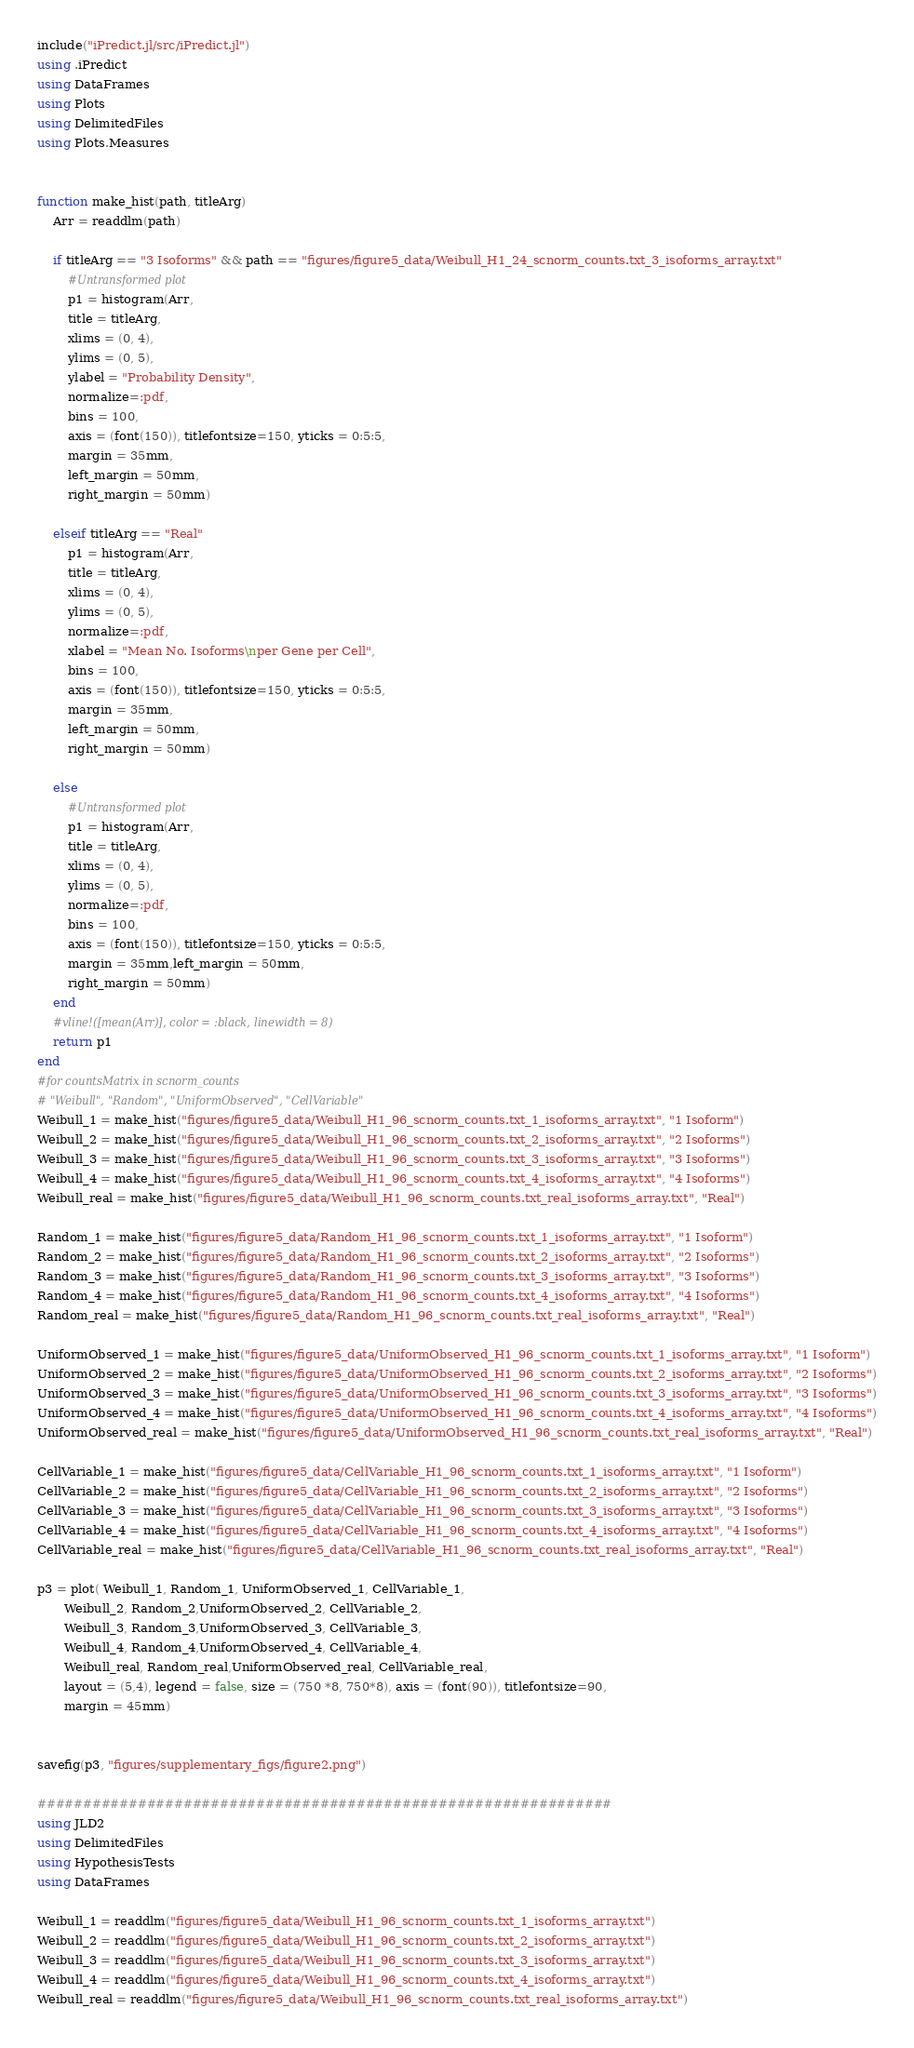<code> <loc_0><loc_0><loc_500><loc_500><_Julia_>include("iPredict.jl/src/iPredict.jl")
using .iPredict
using DataFrames
using Plots
using DelimitedFiles
using Plots.Measures


function make_hist(path, titleArg)
    Arr = readdlm(path)

    if titleArg == "3 Isoforms" && path == "figures/figure5_data/Weibull_H1_24_scnorm_counts.txt_3_isoforms_array.txt"
        #Untransformed plot
        p1 = histogram(Arr,
        title = titleArg,
        xlims = (0, 4),
        ylims = (0, 5),
        ylabel = "Probability Density",
        normalize=:pdf,
        bins = 100,
        axis = (font(150)), titlefontsize=150, yticks = 0:5:5,
        margin = 35mm,
        left_margin = 50mm,
        right_margin = 50mm)

    elseif titleArg == "Real"
        p1 = histogram(Arr,
        title = titleArg,
        xlims = (0, 4),
        ylims = (0, 5),
        normalize=:pdf,
        xlabel = "Mean No. Isoforms\nper Gene per Cell",
        bins = 100,
        axis = (font(150)), titlefontsize=150, yticks = 0:5:5,
        margin = 35mm,
        left_margin = 50mm,
        right_margin = 50mm)

    else
        #Untransformed plot
        p1 = histogram(Arr,
        title = titleArg,
        xlims = (0, 4),
        ylims = (0, 5),
        normalize=:pdf,
        bins = 100,
        axis = (font(150)), titlefontsize=150, yticks = 0:5:5,
        margin = 35mm,left_margin = 50mm,
        right_margin = 50mm)
    end
    #vline!([mean(Arr)], color = :black, linewidth = 8)
    return p1
end
#for countsMatrix in scnorm_counts
# "Weibull", "Random", "UniformObserved", "CellVariable"
Weibull_1 = make_hist("figures/figure5_data/Weibull_H1_96_scnorm_counts.txt_1_isoforms_array.txt", "1 Isoform")
Weibull_2 = make_hist("figures/figure5_data/Weibull_H1_96_scnorm_counts.txt_2_isoforms_array.txt", "2 Isoforms")
Weibull_3 = make_hist("figures/figure5_data/Weibull_H1_96_scnorm_counts.txt_3_isoforms_array.txt", "3 Isoforms")
Weibull_4 = make_hist("figures/figure5_data/Weibull_H1_96_scnorm_counts.txt_4_isoforms_array.txt", "4 Isoforms")
Weibull_real = make_hist("figures/figure5_data/Weibull_H1_96_scnorm_counts.txt_real_isoforms_array.txt", "Real")

Random_1 = make_hist("figures/figure5_data/Random_H1_96_scnorm_counts.txt_1_isoforms_array.txt", "1 Isoform")
Random_2 = make_hist("figures/figure5_data/Random_H1_96_scnorm_counts.txt_2_isoforms_array.txt", "2 Isoforms")
Random_3 = make_hist("figures/figure5_data/Random_H1_96_scnorm_counts.txt_3_isoforms_array.txt", "3 Isoforms")
Random_4 = make_hist("figures/figure5_data/Random_H1_96_scnorm_counts.txt_4_isoforms_array.txt", "4 Isoforms")
Random_real = make_hist("figures/figure5_data/Random_H1_96_scnorm_counts.txt_real_isoforms_array.txt", "Real")

UniformObserved_1 = make_hist("figures/figure5_data/UniformObserved_H1_96_scnorm_counts.txt_1_isoforms_array.txt", "1 Isoform")
UniformObserved_2 = make_hist("figures/figure5_data/UniformObserved_H1_96_scnorm_counts.txt_2_isoforms_array.txt", "2 Isoforms")
UniformObserved_3 = make_hist("figures/figure5_data/UniformObserved_H1_96_scnorm_counts.txt_3_isoforms_array.txt", "3 Isoforms")
UniformObserved_4 = make_hist("figures/figure5_data/UniformObserved_H1_96_scnorm_counts.txt_4_isoforms_array.txt", "4 Isoforms")
UniformObserved_real = make_hist("figures/figure5_data/UniformObserved_H1_96_scnorm_counts.txt_real_isoforms_array.txt", "Real")

CellVariable_1 = make_hist("figures/figure5_data/CellVariable_H1_96_scnorm_counts.txt_1_isoforms_array.txt", "1 Isoform")
CellVariable_2 = make_hist("figures/figure5_data/CellVariable_H1_96_scnorm_counts.txt_2_isoforms_array.txt", "2 Isoforms")
CellVariable_3 = make_hist("figures/figure5_data/CellVariable_H1_96_scnorm_counts.txt_3_isoforms_array.txt", "3 Isoforms")
CellVariable_4 = make_hist("figures/figure5_data/CellVariable_H1_96_scnorm_counts.txt_4_isoforms_array.txt", "4 Isoforms")
CellVariable_real = make_hist("figures/figure5_data/CellVariable_H1_96_scnorm_counts.txt_real_isoforms_array.txt", "Real")

p3 = plot( Weibull_1, Random_1, UniformObserved_1, CellVariable_1,
       Weibull_2, Random_2,UniformObserved_2, CellVariable_2,
       Weibull_3, Random_3,UniformObserved_3, CellVariable_3,
       Weibull_4, Random_4,UniformObserved_4, CellVariable_4,
       Weibull_real, Random_real,UniformObserved_real, CellVariable_real,
       layout = (5,4), legend = false, size = (750 *8, 750*8), axis = (font(90)), titlefontsize=90,
       margin = 45mm)


savefig(p3, "figures/supplementary_figs/figure2.png")

###############################################################
using JLD2
using DelimitedFiles
using HypothesisTests
using DataFrames

Weibull_1 = readdlm("figures/figure5_data/Weibull_H1_96_scnorm_counts.txt_1_isoforms_array.txt")
Weibull_2 = readdlm("figures/figure5_data/Weibull_H1_96_scnorm_counts.txt_2_isoforms_array.txt")
Weibull_3 = readdlm("figures/figure5_data/Weibull_H1_96_scnorm_counts.txt_3_isoforms_array.txt")
Weibull_4 = readdlm("figures/figure5_data/Weibull_H1_96_scnorm_counts.txt_4_isoforms_array.txt")
Weibull_real = readdlm("figures/figure5_data/Weibull_H1_96_scnorm_counts.txt_real_isoforms_array.txt")
</code> 